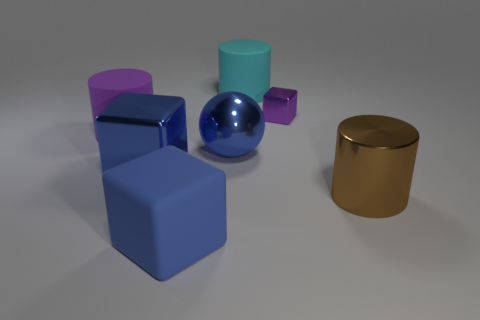How many small objects are either blue rubber cubes or blue metallic cylinders?
Ensure brevity in your answer.  0. Is the color of the cylinder left of the cyan object the same as the cube that is on the right side of the big cyan matte cylinder?
Give a very brief answer. Yes. What number of other things are the same color as the large metal block?
Your answer should be compact. 2. How many yellow things are large matte cylinders or large cubes?
Your response must be concise. 0. Do the purple metal thing and the shiny object to the left of the big shiny sphere have the same shape?
Provide a succinct answer. Yes. The big cyan object has what shape?
Give a very brief answer. Cylinder. There is a cyan cylinder that is the same size as the blue metal block; what material is it?
Provide a succinct answer. Rubber. Is there anything else that is the same size as the purple metal object?
Offer a very short reply. No. What number of things are either cyan objects or metal things that are to the left of the matte block?
Give a very brief answer. 2. What size is the purple cube that is the same material as the big brown cylinder?
Provide a succinct answer. Small. 